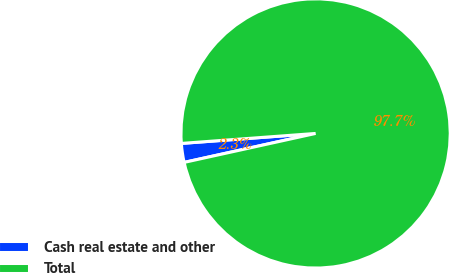Convert chart. <chart><loc_0><loc_0><loc_500><loc_500><pie_chart><fcel>Cash real estate and other<fcel>Total<nl><fcel>2.27%<fcel>97.73%<nl></chart> 